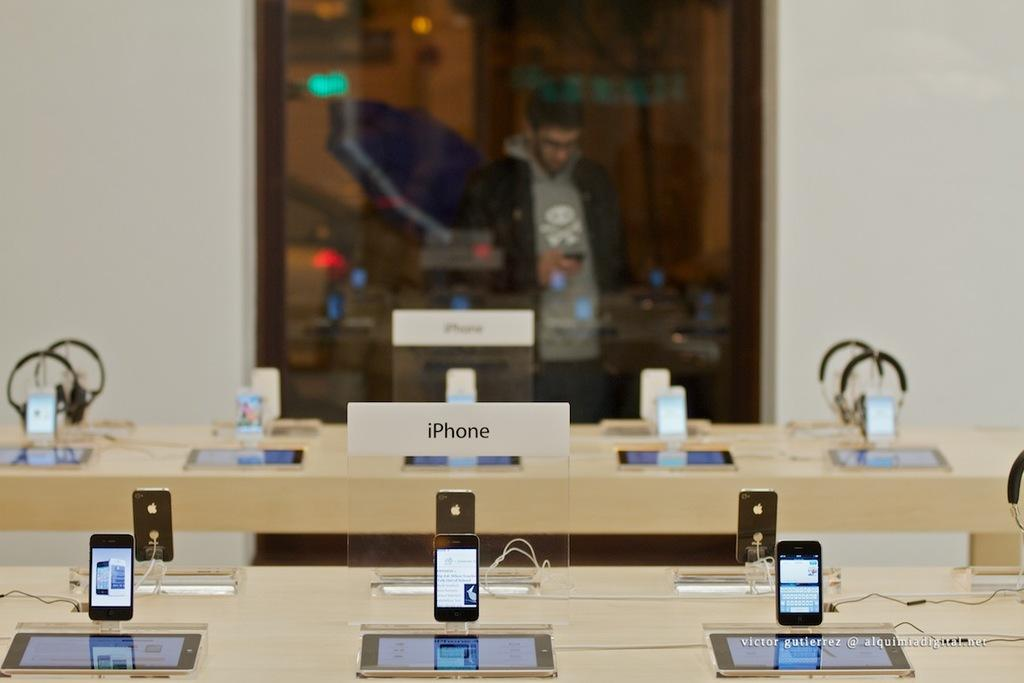<image>
Create a compact narrative representing the image presented. Victor Gutierrez captured a picture of an Iphone Display inside an Apple store 